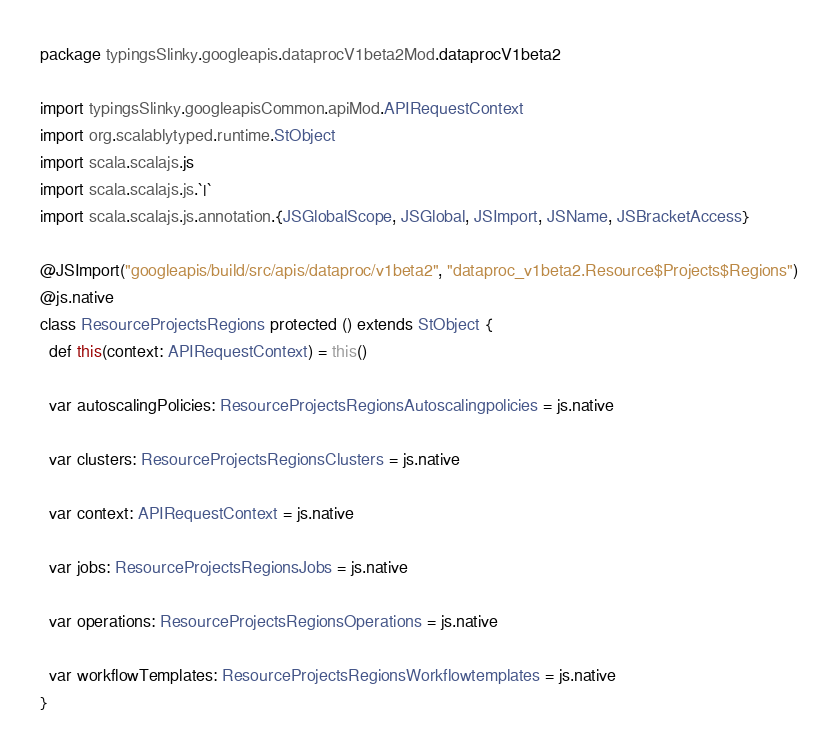Convert code to text. <code><loc_0><loc_0><loc_500><loc_500><_Scala_>package typingsSlinky.googleapis.dataprocV1beta2Mod.dataprocV1beta2

import typingsSlinky.googleapisCommon.apiMod.APIRequestContext
import org.scalablytyped.runtime.StObject
import scala.scalajs.js
import scala.scalajs.js.`|`
import scala.scalajs.js.annotation.{JSGlobalScope, JSGlobal, JSImport, JSName, JSBracketAccess}

@JSImport("googleapis/build/src/apis/dataproc/v1beta2", "dataproc_v1beta2.Resource$Projects$Regions")
@js.native
class ResourceProjectsRegions protected () extends StObject {
  def this(context: APIRequestContext) = this()
  
  var autoscalingPolicies: ResourceProjectsRegionsAutoscalingpolicies = js.native
  
  var clusters: ResourceProjectsRegionsClusters = js.native
  
  var context: APIRequestContext = js.native
  
  var jobs: ResourceProjectsRegionsJobs = js.native
  
  var operations: ResourceProjectsRegionsOperations = js.native
  
  var workflowTemplates: ResourceProjectsRegionsWorkflowtemplates = js.native
}
</code> 